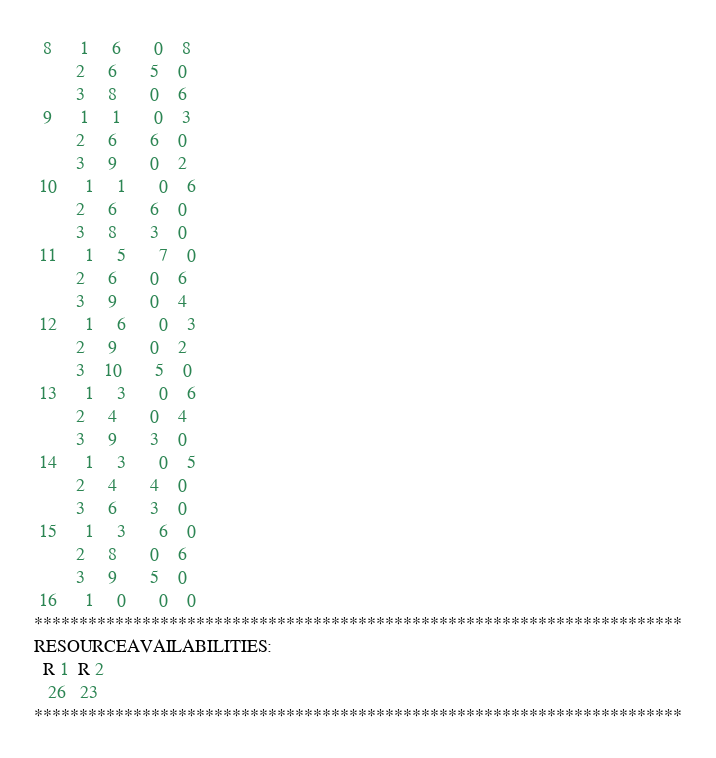Convert code to text. <code><loc_0><loc_0><loc_500><loc_500><_ObjectiveC_>  8      1     6       0    8
         2     6       5    0
         3     8       0    6
  9      1     1       0    3
         2     6       6    0
         3     9       0    2
 10      1     1       0    6
         2     6       6    0
         3     8       3    0
 11      1     5       7    0
         2     6       0    6
         3     9       0    4
 12      1     6       0    3
         2     9       0    2
         3    10       5    0
 13      1     3       0    6
         2     4       0    4
         3     9       3    0
 14      1     3       0    5
         2     4       4    0
         3     6       3    0
 15      1     3       6    0
         2     8       0    6
         3     9       5    0
 16      1     0       0    0
************************************************************************
RESOURCEAVAILABILITIES:
  R 1  R 2
   26   23
************************************************************************
</code> 